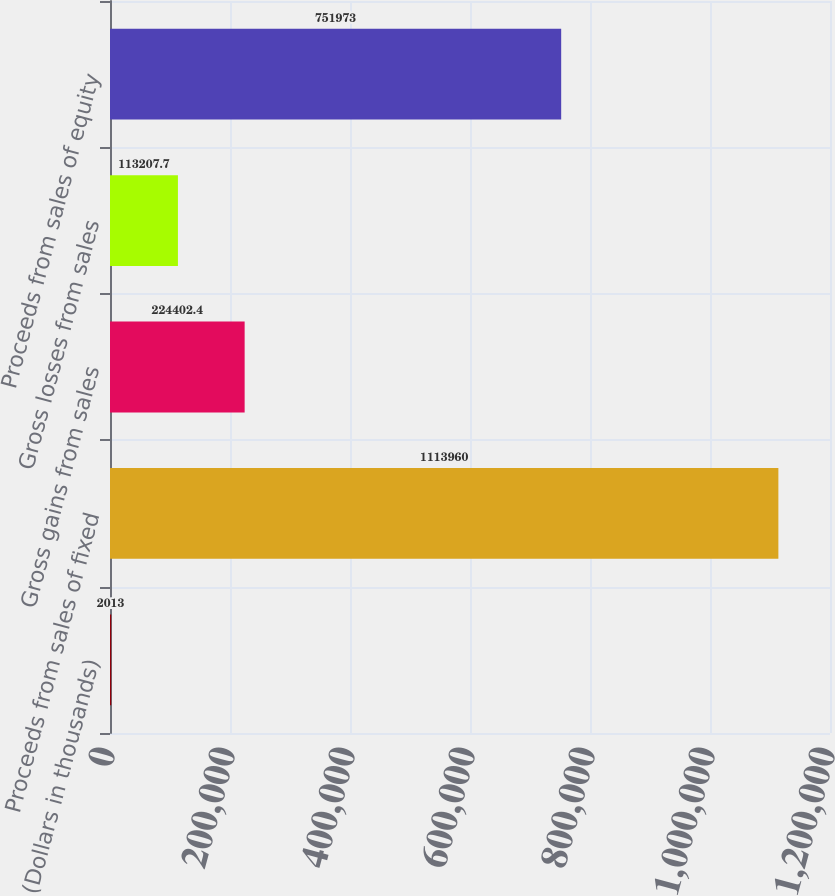Convert chart. <chart><loc_0><loc_0><loc_500><loc_500><bar_chart><fcel>(Dollars in thousands)<fcel>Proceeds from sales of fixed<fcel>Gross gains from sales<fcel>Gross losses from sales<fcel>Proceeds from sales of equity<nl><fcel>2013<fcel>1.11396e+06<fcel>224402<fcel>113208<fcel>751973<nl></chart> 